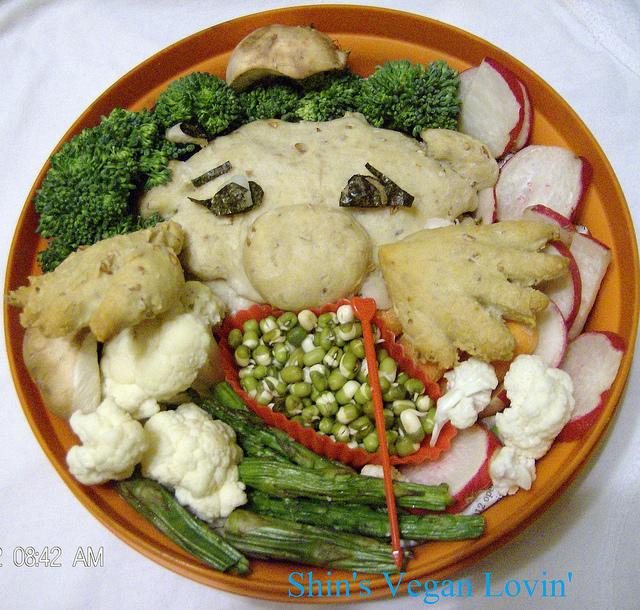Is the food arranged to look like a face?
Quick response, please. Yes. Is there any radish on the plate?
Be succinct. Yes. What kind of bowl is this?
Short answer required. Orange. 